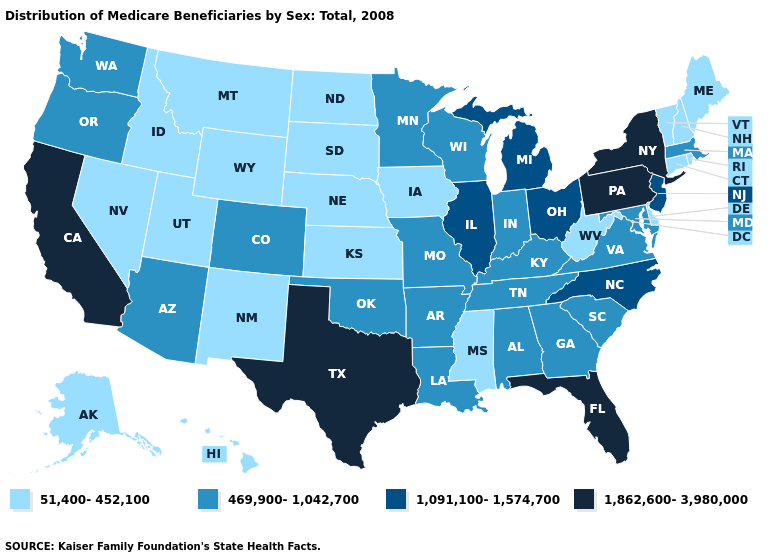What is the lowest value in the USA?
Short answer required. 51,400-452,100. Name the states that have a value in the range 1,862,600-3,980,000?
Give a very brief answer. California, Florida, New York, Pennsylvania, Texas. Does Wisconsin have the lowest value in the MidWest?
Answer briefly. No. Name the states that have a value in the range 51,400-452,100?
Keep it brief. Alaska, Connecticut, Delaware, Hawaii, Idaho, Iowa, Kansas, Maine, Mississippi, Montana, Nebraska, Nevada, New Hampshire, New Mexico, North Dakota, Rhode Island, South Dakota, Utah, Vermont, West Virginia, Wyoming. What is the highest value in the USA?
Be succinct. 1,862,600-3,980,000. Name the states that have a value in the range 1,091,100-1,574,700?
Be succinct. Illinois, Michigan, New Jersey, North Carolina, Ohio. What is the lowest value in the West?
Short answer required. 51,400-452,100. Does Arizona have the highest value in the West?
Answer briefly. No. Which states have the highest value in the USA?
Answer briefly. California, Florida, New York, Pennsylvania, Texas. Which states have the lowest value in the USA?
Give a very brief answer. Alaska, Connecticut, Delaware, Hawaii, Idaho, Iowa, Kansas, Maine, Mississippi, Montana, Nebraska, Nevada, New Hampshire, New Mexico, North Dakota, Rhode Island, South Dakota, Utah, Vermont, West Virginia, Wyoming. Does Iowa have a lower value than Georgia?
Write a very short answer. Yes. Does the first symbol in the legend represent the smallest category?
Short answer required. Yes. What is the value of Iowa?
Write a very short answer. 51,400-452,100. Does Illinois have the same value as Ohio?
Give a very brief answer. Yes. 